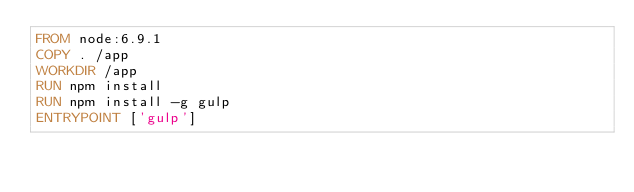Convert code to text. <code><loc_0><loc_0><loc_500><loc_500><_Dockerfile_>FROM node:6.9.1
COPY . /app
WORKDIR /app
RUN npm install
RUN npm install -g gulp
ENTRYPOINT ['gulp']
</code> 